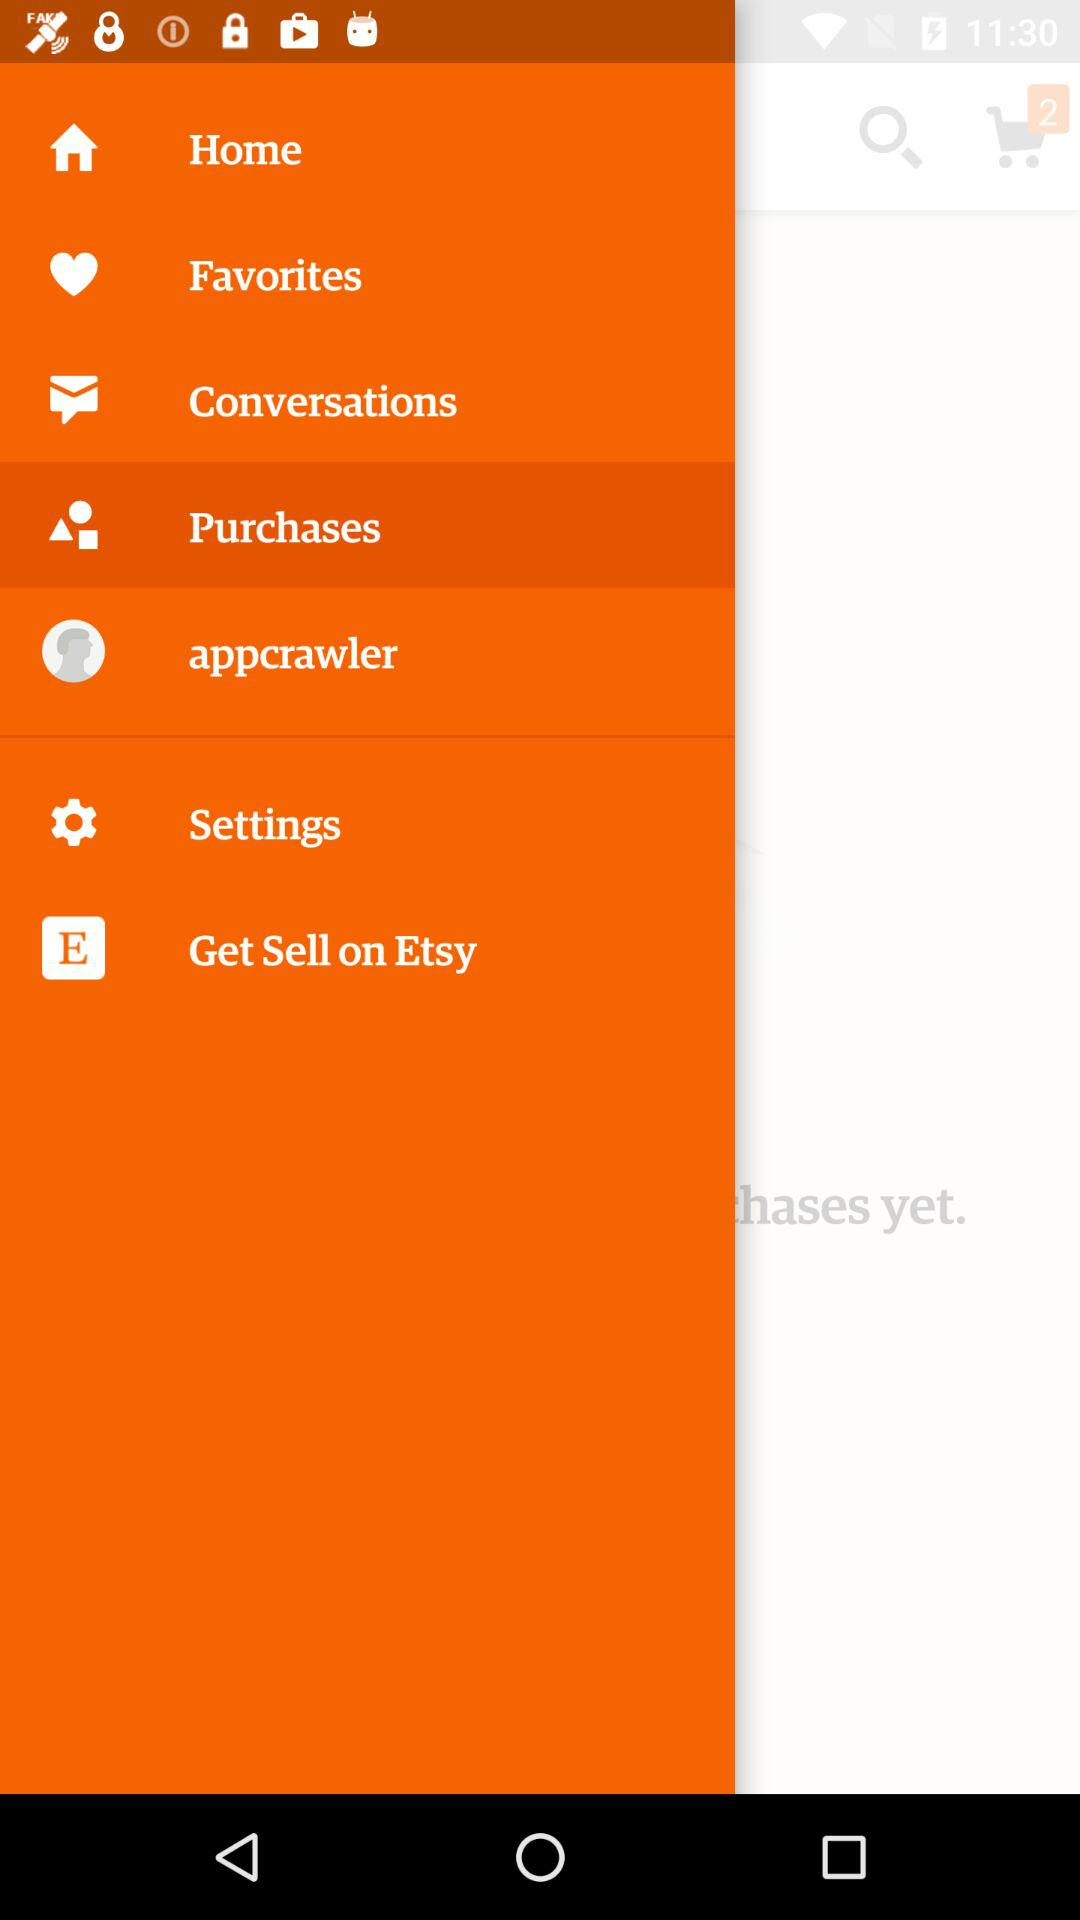Which items are listed in "Favorites"?
When the provided information is insufficient, respond with <no answer>. <no answer> 